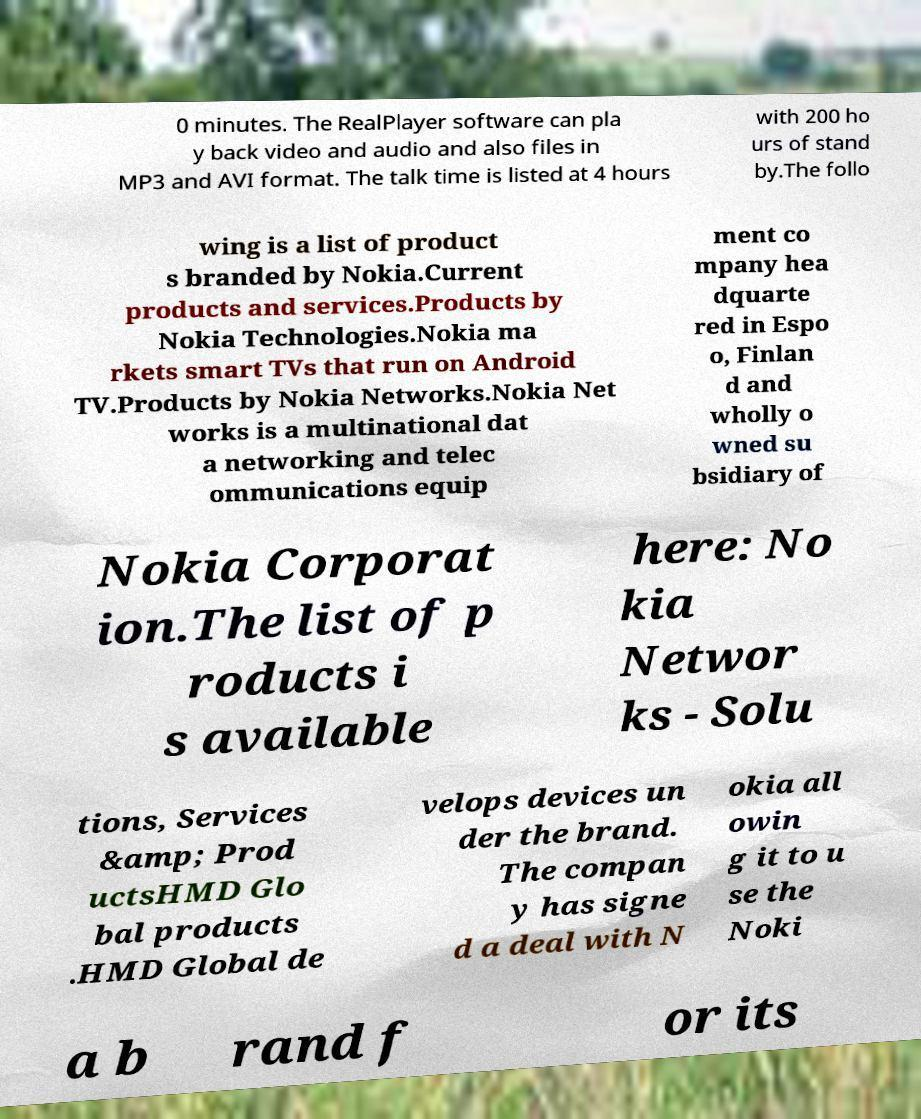Can you accurately transcribe the text from the provided image for me? 0 minutes. The RealPlayer software can pla y back video and audio and also files in MP3 and AVI format. The talk time is listed at 4 hours with 200 ho urs of stand by.The follo wing is a list of product s branded by Nokia.Current products and services.Products by Nokia Technologies.Nokia ma rkets smart TVs that run on Android TV.Products by Nokia Networks.Nokia Net works is a multinational dat a networking and telec ommunications equip ment co mpany hea dquarte red in Espo o, Finlan d and wholly o wned su bsidiary of Nokia Corporat ion.The list of p roducts i s available here: No kia Networ ks - Solu tions, Services &amp; Prod uctsHMD Glo bal products .HMD Global de velops devices un der the brand. The compan y has signe d a deal with N okia all owin g it to u se the Noki a b rand f or its 